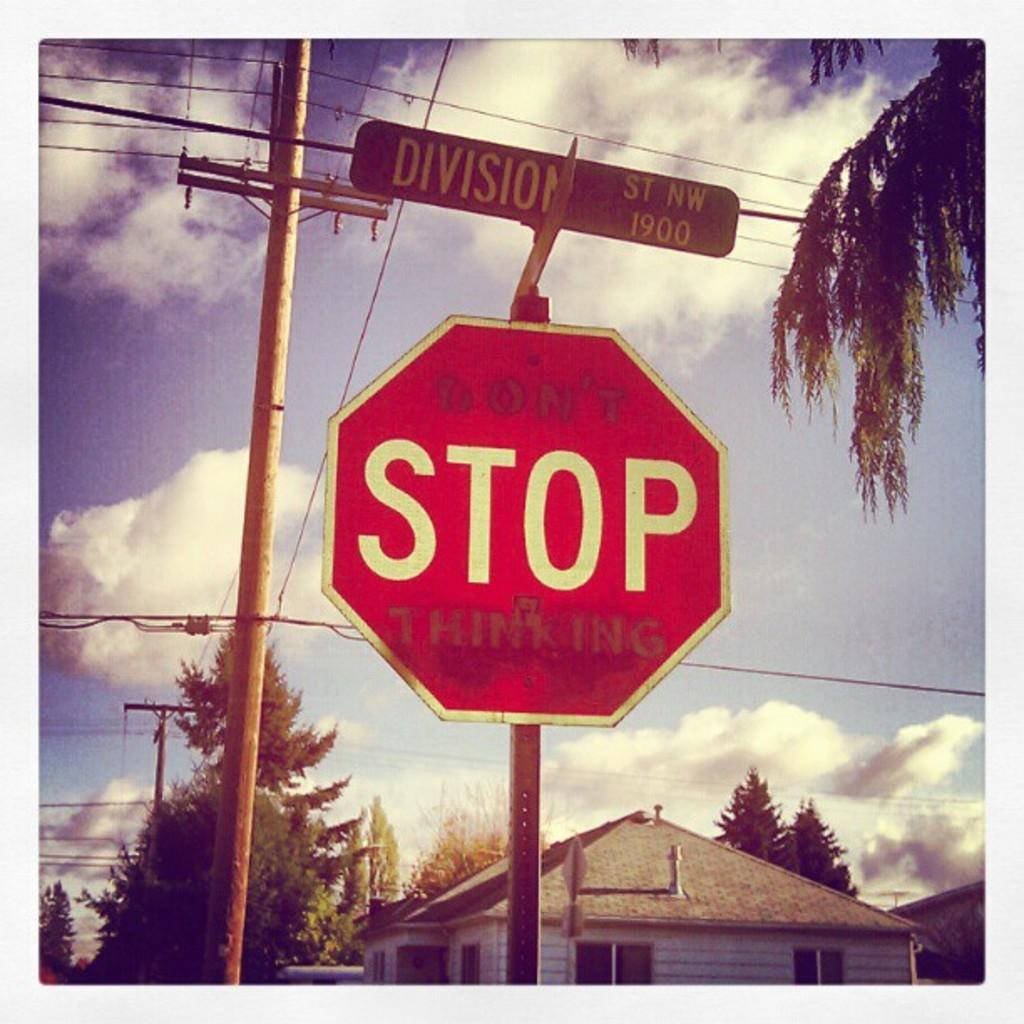<image>
Give a short and clear explanation of the subsequent image. A stop sign at Division St. that says Don't stop thinking. 